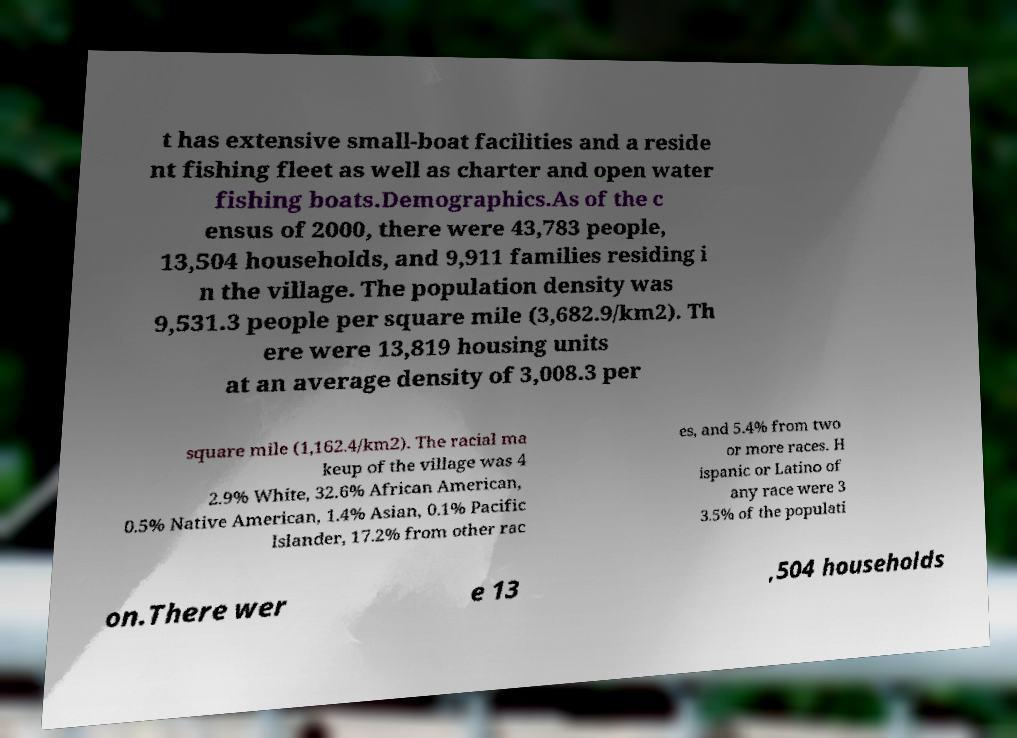I need the written content from this picture converted into text. Can you do that? t has extensive small-boat facilities and a reside nt fishing fleet as well as charter and open water fishing boats.Demographics.As of the c ensus of 2000, there were 43,783 people, 13,504 households, and 9,911 families residing i n the village. The population density was 9,531.3 people per square mile (3,682.9/km2). Th ere were 13,819 housing units at an average density of 3,008.3 per square mile (1,162.4/km2). The racial ma keup of the village was 4 2.9% White, 32.6% African American, 0.5% Native American, 1.4% Asian, 0.1% Pacific Islander, 17.2% from other rac es, and 5.4% from two or more races. H ispanic or Latino of any race were 3 3.5% of the populati on.There wer e 13 ,504 households 